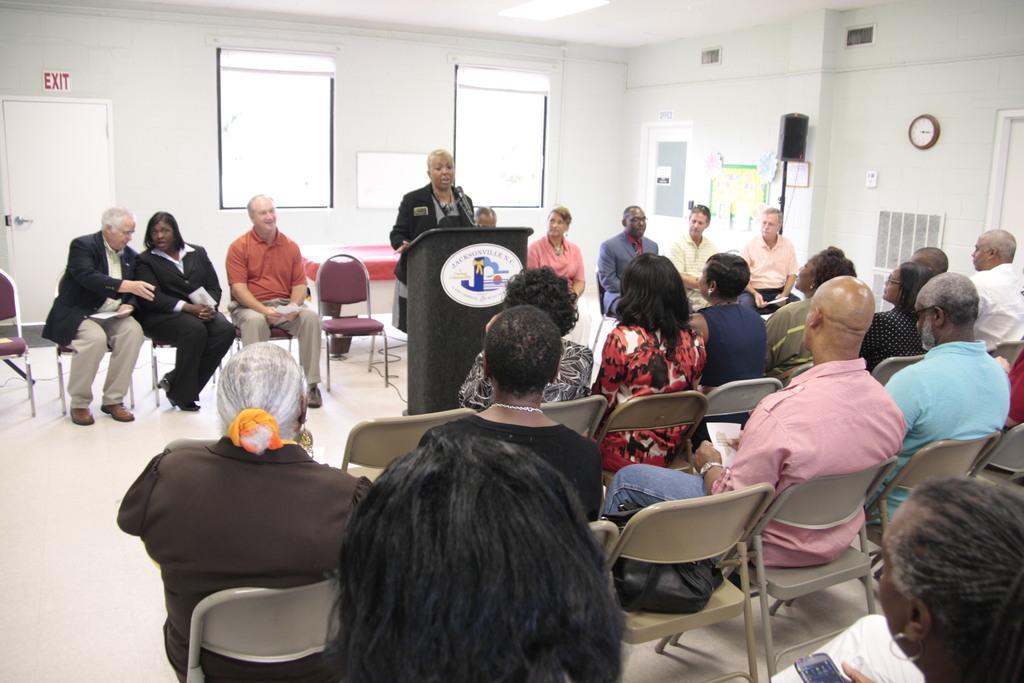Can you describe this image briefly? This is an inside view of a room. On the right side, I can see few people are sitting on the chairs. In front of these people there are some more people sitting facing towards these people. In the middle of this image I can see a person standing in front of the podium and speaking on the mike. In the background, I can see a wall along with the windows and a door. There are some posters attached to the wall. On the right side, I can see a clock is attached to the wall. 